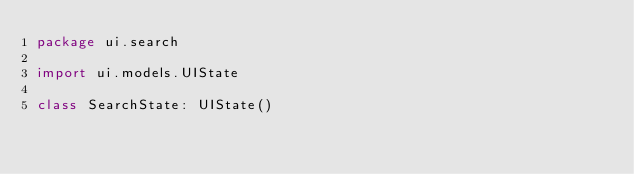Convert code to text. <code><loc_0><loc_0><loc_500><loc_500><_Kotlin_>package ui.search

import ui.models.UIState

class SearchState: UIState()</code> 